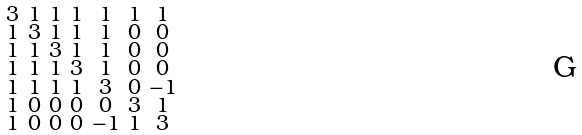<formula> <loc_0><loc_0><loc_500><loc_500>\begin{smallmatrix} 3 & 1 & 1 & 1 & 1 & 1 & 1 \\ 1 & 3 & 1 & 1 & 1 & 0 & 0 \\ 1 & 1 & 3 & 1 & 1 & 0 & 0 \\ 1 & 1 & 1 & 3 & 1 & 0 & 0 \\ 1 & 1 & 1 & 1 & 3 & 0 & - 1 \\ 1 & 0 & 0 & 0 & 0 & 3 & 1 \\ 1 & 0 & 0 & 0 & - 1 & 1 & 3 \end{smallmatrix}</formula> 